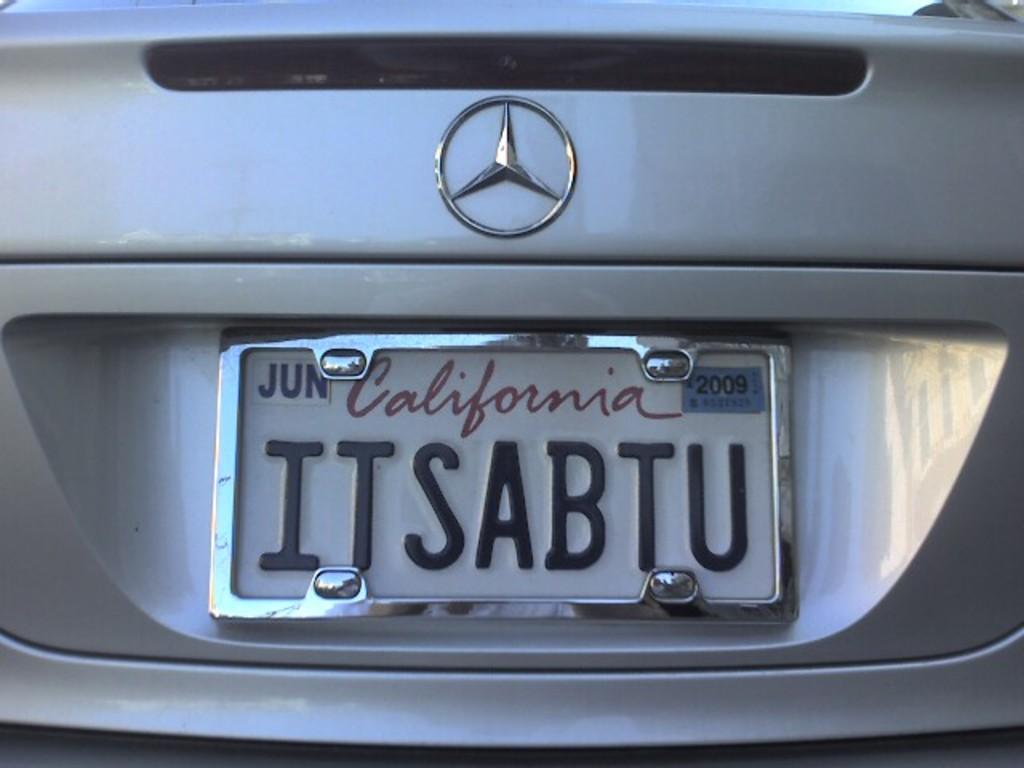What type of vehicle is in the picture? There is a car in the picture. What brand is the car? The car has a Benz symbol, indicating it is a Mercedes-Benz. Does the car have a registration plate? Yes, the car has a registration plate. What is written on the registration plate? There is text on the registration plate, but it cannot be read from the image. What color is the car? The car is grey in color. How many pickles are on the car's hood in the image? There are no pickles present on the car's hood in the image. What type of patch is visible on the car's roof in the image? There is no patch visible on the car's roof in the image. 